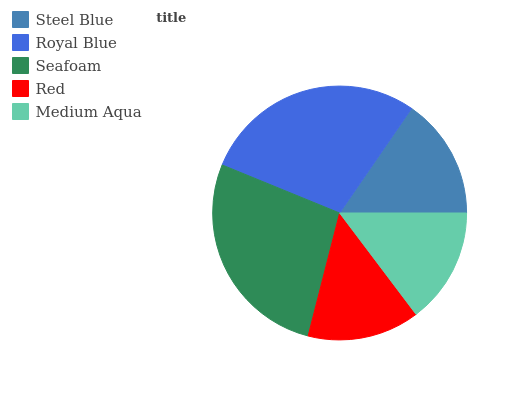Is Red the minimum?
Answer yes or no. Yes. Is Royal Blue the maximum?
Answer yes or no. Yes. Is Seafoam the minimum?
Answer yes or no. No. Is Seafoam the maximum?
Answer yes or no. No. Is Royal Blue greater than Seafoam?
Answer yes or no. Yes. Is Seafoam less than Royal Blue?
Answer yes or no. Yes. Is Seafoam greater than Royal Blue?
Answer yes or no. No. Is Royal Blue less than Seafoam?
Answer yes or no. No. Is Steel Blue the high median?
Answer yes or no. Yes. Is Steel Blue the low median?
Answer yes or no. Yes. Is Seafoam the high median?
Answer yes or no. No. Is Royal Blue the low median?
Answer yes or no. No. 